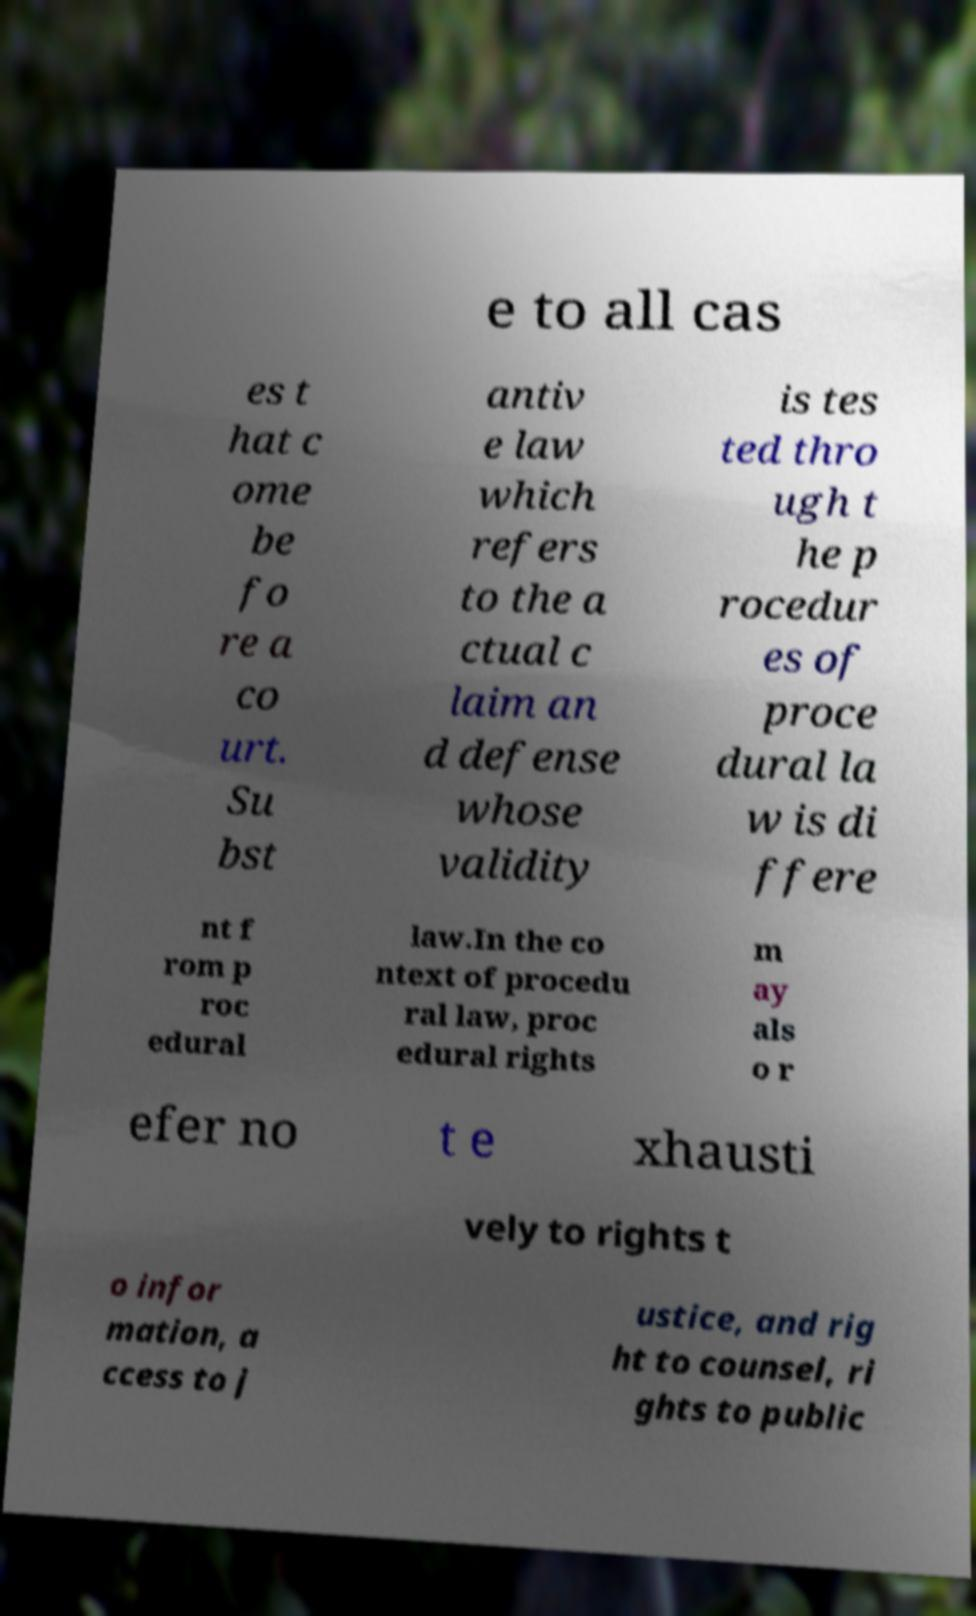Can you accurately transcribe the text from the provided image for me? e to all cas es t hat c ome be fo re a co urt. Su bst antiv e law which refers to the a ctual c laim an d defense whose validity is tes ted thro ugh t he p rocedur es of proce dural la w is di ffere nt f rom p roc edural law.In the co ntext of procedu ral law, proc edural rights m ay als o r efer no t e xhausti vely to rights t o infor mation, a ccess to j ustice, and rig ht to counsel, ri ghts to public 